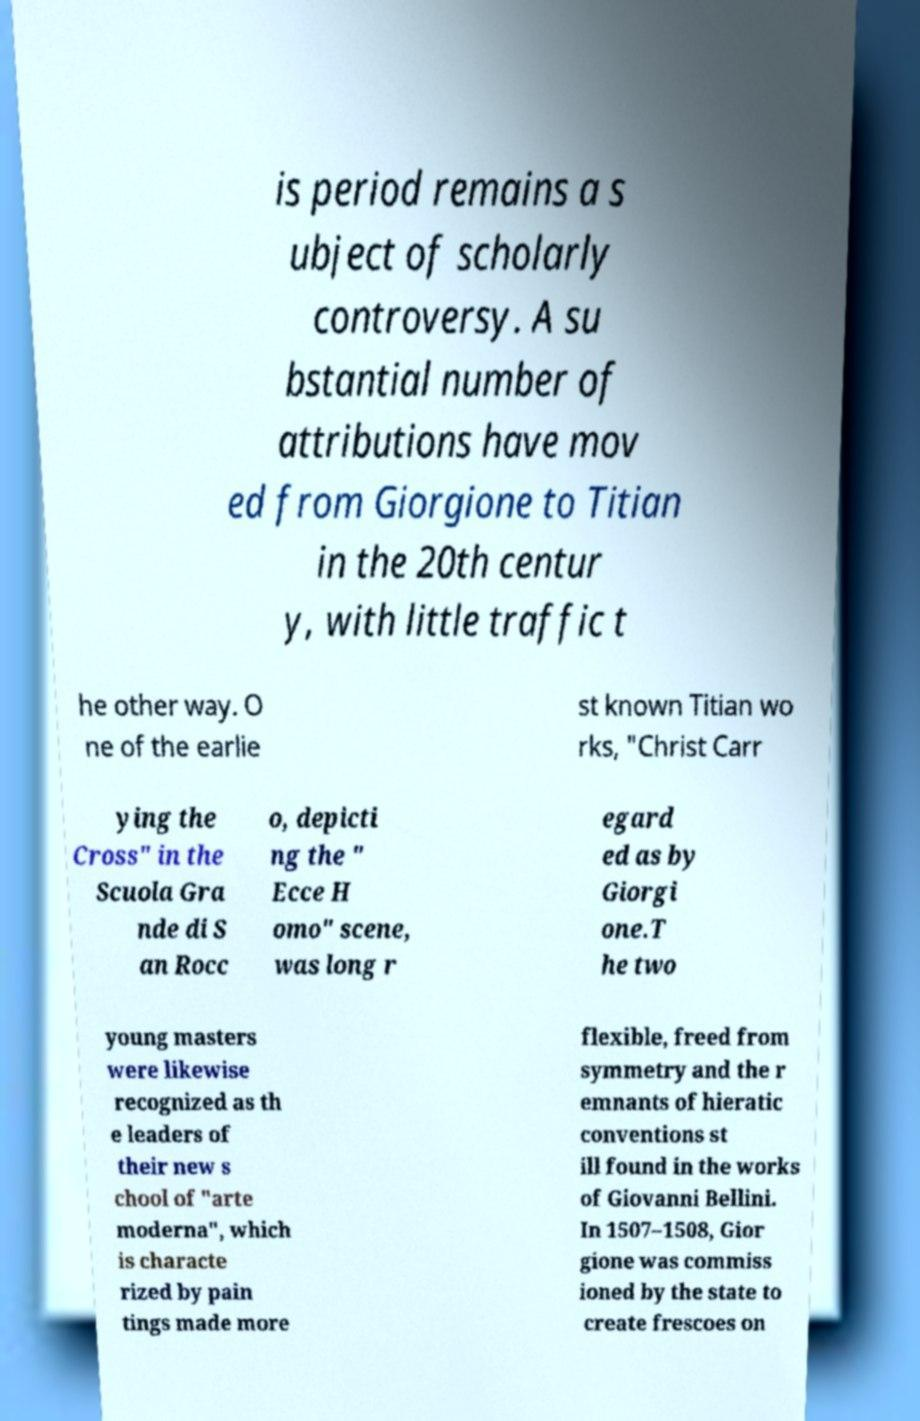There's text embedded in this image that I need extracted. Can you transcribe it verbatim? is period remains a s ubject of scholarly controversy. A su bstantial number of attributions have mov ed from Giorgione to Titian in the 20th centur y, with little traffic t he other way. O ne of the earlie st known Titian wo rks, "Christ Carr ying the Cross" in the Scuola Gra nde di S an Rocc o, depicti ng the " Ecce H omo" scene, was long r egard ed as by Giorgi one.T he two young masters were likewise recognized as th e leaders of their new s chool of "arte moderna", which is characte rized by pain tings made more flexible, freed from symmetry and the r emnants of hieratic conventions st ill found in the works of Giovanni Bellini. In 1507–1508, Gior gione was commiss ioned by the state to create frescoes on 